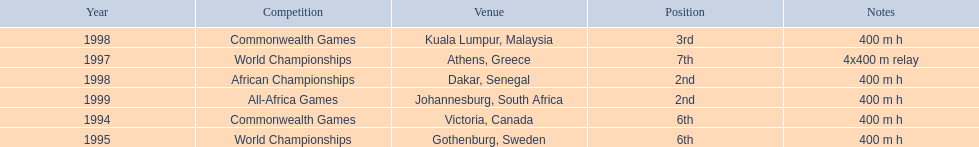Which year had the most competitions? 1998. 